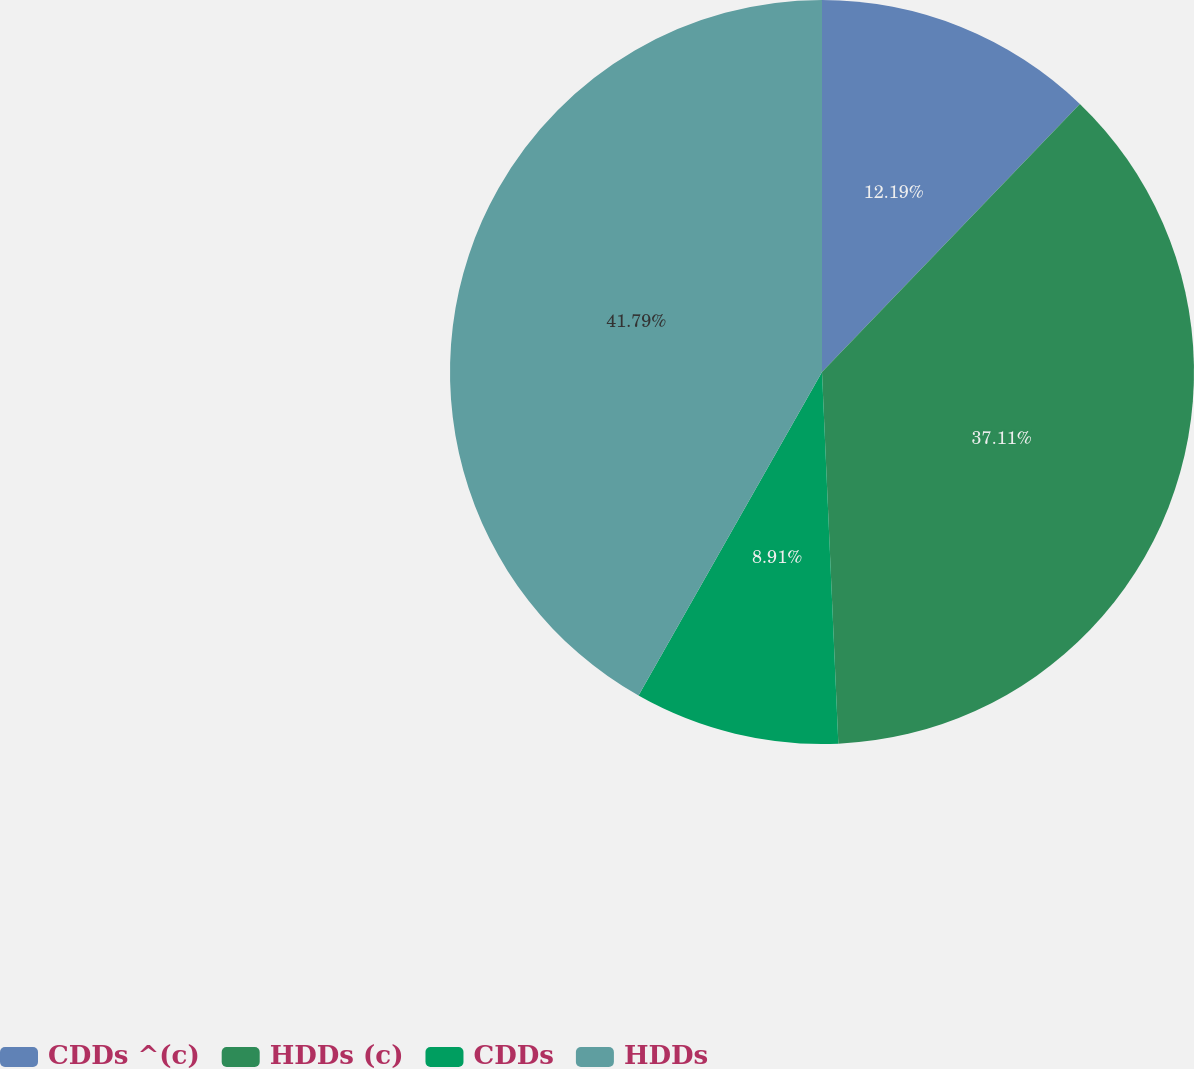Convert chart. <chart><loc_0><loc_0><loc_500><loc_500><pie_chart><fcel>CDDs ^(c)<fcel>HDDs (c)<fcel>CDDs<fcel>HDDs<nl><fcel>12.19%<fcel>37.11%<fcel>8.91%<fcel>41.79%<nl></chart> 